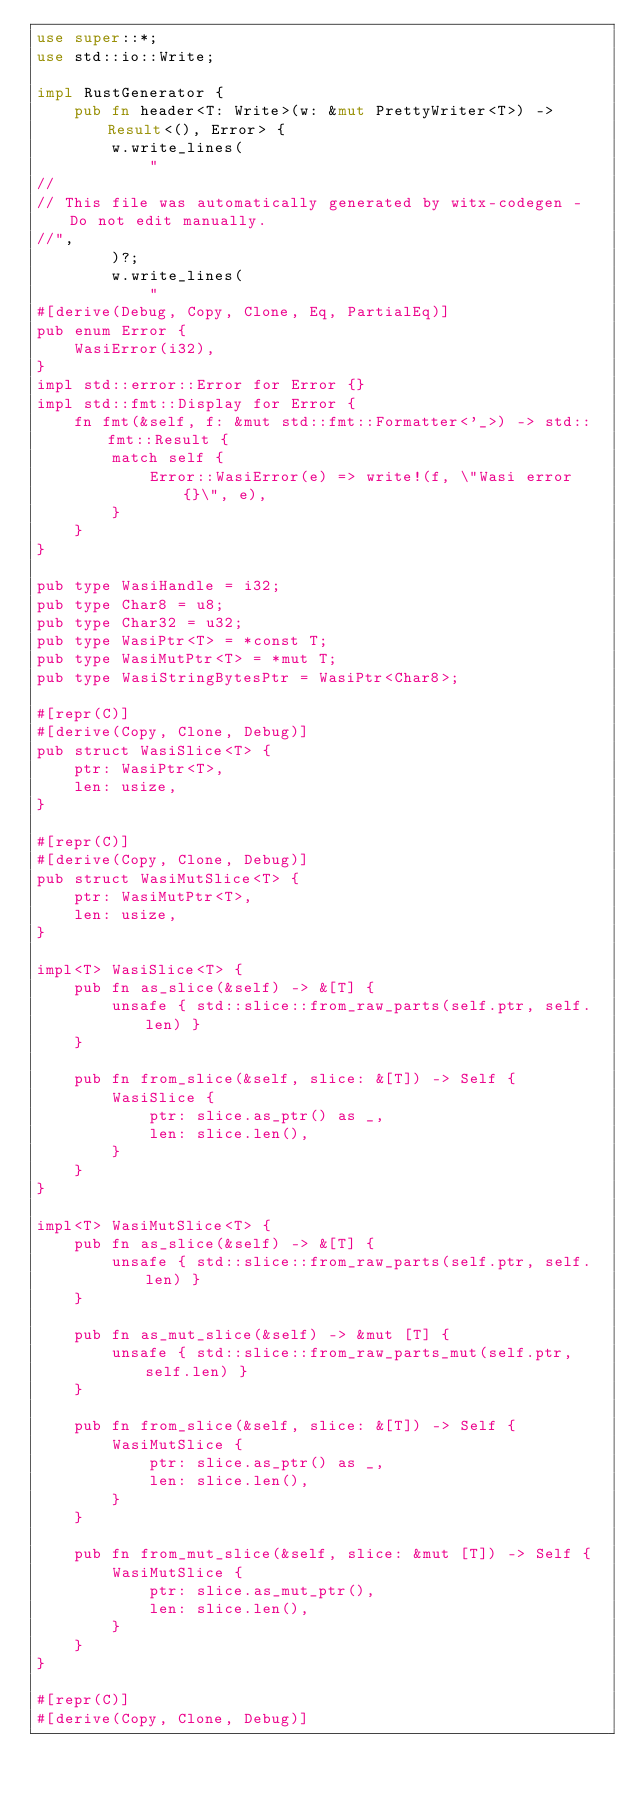<code> <loc_0><loc_0><loc_500><loc_500><_Rust_>use super::*;
use std::io::Write;

impl RustGenerator {
    pub fn header<T: Write>(w: &mut PrettyWriter<T>) -> Result<(), Error> {
        w.write_lines(
            "
//
// This file was automatically generated by witx-codegen - Do not edit manually.
//",
        )?;
        w.write_lines(
            "
#[derive(Debug, Copy, Clone, Eq, PartialEq)]
pub enum Error {
    WasiError(i32),
}
impl std::error::Error for Error {}
impl std::fmt::Display for Error {
    fn fmt(&self, f: &mut std::fmt::Formatter<'_>) -> std::fmt::Result {
        match self {
            Error::WasiError(e) => write!(f, \"Wasi error {}\", e),
        }
    }
}

pub type WasiHandle = i32;
pub type Char8 = u8;
pub type Char32 = u32;
pub type WasiPtr<T> = *const T;
pub type WasiMutPtr<T> = *mut T;
pub type WasiStringBytesPtr = WasiPtr<Char8>;

#[repr(C)]
#[derive(Copy, Clone, Debug)]
pub struct WasiSlice<T> {
    ptr: WasiPtr<T>,
    len: usize,
}

#[repr(C)]
#[derive(Copy, Clone, Debug)]
pub struct WasiMutSlice<T> {
    ptr: WasiMutPtr<T>,
    len: usize,
}

impl<T> WasiSlice<T> {
    pub fn as_slice(&self) -> &[T] {
        unsafe { std::slice::from_raw_parts(self.ptr, self.len) }
    }

    pub fn from_slice(&self, slice: &[T]) -> Self {
        WasiSlice {
            ptr: slice.as_ptr() as _,
            len: slice.len(),
        }
    }
}

impl<T> WasiMutSlice<T> {
    pub fn as_slice(&self) -> &[T] {
        unsafe { std::slice::from_raw_parts(self.ptr, self.len) }
    }

    pub fn as_mut_slice(&self) -> &mut [T] {
        unsafe { std::slice::from_raw_parts_mut(self.ptr, self.len) }
    }

    pub fn from_slice(&self, slice: &[T]) -> Self {
        WasiMutSlice {
            ptr: slice.as_ptr() as _,
            len: slice.len(),
        }
    }

    pub fn from_mut_slice(&self, slice: &mut [T]) -> Self {
        WasiMutSlice {
            ptr: slice.as_mut_ptr(),
            len: slice.len(),
        }
    }
}

#[repr(C)]
#[derive(Copy, Clone, Debug)]</code> 